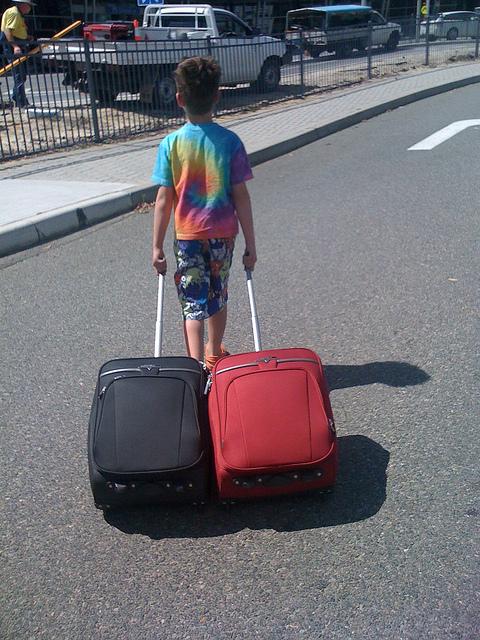What color is his luggage?
Short answer required. Red and black. Can you put clothes in what the person is carrying?
Give a very brief answer. Yes. Is an adult pulling the luggage?
Keep it brief. No. What color is the suitcase on the right?
Keep it brief. Red. 